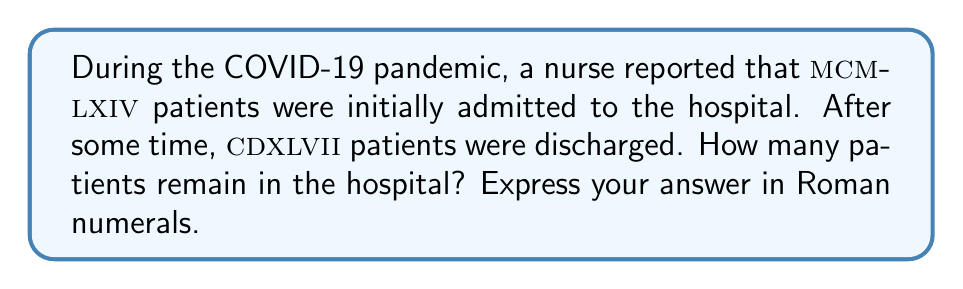Could you help me with this problem? Let's solve this problem step by step:

1) First, we need to convert the Roman numerals to Arabic numerals:

   MCMLXIV = 1000 + (1000 - 100) + 50 + 10 + (5 - 1) = 1964
   CDXLVII = (500 - 100) + 40 + 5 + 1 + 1 = 447

2) Now we can perform the subtraction:

   1964 - 447 = 1517

3) Finally, we need to convert 1517 back to Roman numerals:

   1000 = M
   500 = D
   10 = X
   5 = V
   1 = I

   1517 = 1000 + 500 + 10 + 5 + 1 + 1 = MDXVII

Therefore, MDXVII patients remain in the hospital.
Answer: MDXVII 